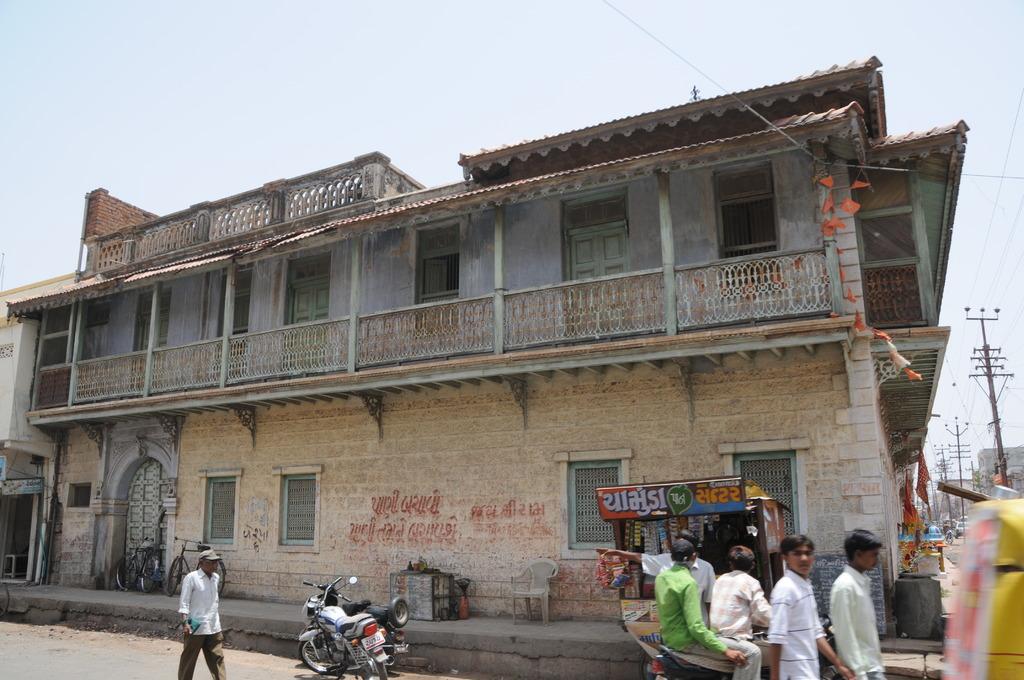Please provide a concise description of this image. In this image we can see a building with windows, doors, the flags and some text on a wall. We can also see some bicycles, chair, a table and a house with roof on a footpath. On the bottom of the image we can see some motor vehicles and a group of people on the road. We can also see some utility poles with wires and the sky which looks cloudy. 